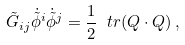Convert formula to latex. <formula><loc_0><loc_0><loc_500><loc_500>\tilde { G } _ { i j } \dot { \tilde { \phi } } ^ { i } \dot { \tilde { \phi } } ^ { j } = \frac { 1 } { 2 } \ t r ( Q \cdot Q ) \, ,</formula> 